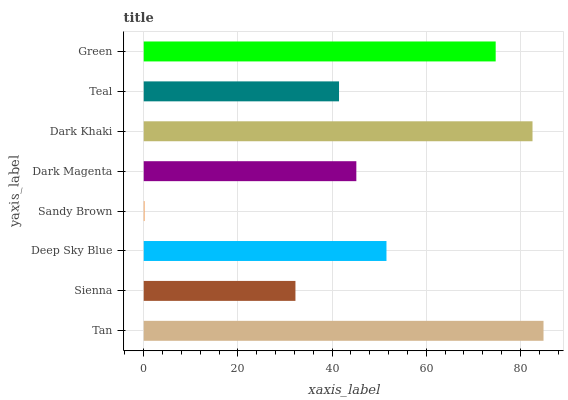Is Sandy Brown the minimum?
Answer yes or no. Yes. Is Tan the maximum?
Answer yes or no. Yes. Is Sienna the minimum?
Answer yes or no. No. Is Sienna the maximum?
Answer yes or no. No. Is Tan greater than Sienna?
Answer yes or no. Yes. Is Sienna less than Tan?
Answer yes or no. Yes. Is Sienna greater than Tan?
Answer yes or no. No. Is Tan less than Sienna?
Answer yes or no. No. Is Deep Sky Blue the high median?
Answer yes or no. Yes. Is Dark Magenta the low median?
Answer yes or no. Yes. Is Teal the high median?
Answer yes or no. No. Is Sandy Brown the low median?
Answer yes or no. No. 